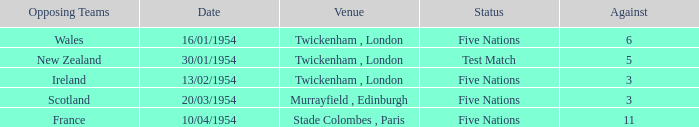What was the venue for the game played on 16/01/1954, when the against was more than 3? Twickenham , London. 